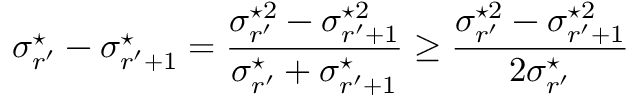Convert formula to latex. <formula><loc_0><loc_0><loc_500><loc_500>\sigma _ { r ^ { \prime } } ^ { ^ { * } } - \sigma _ { r ^ { \prime } + 1 } ^ { ^ { * } } = \frac { \sigma _ { r ^ { \prime } } ^ { ^ { * } 2 } - \sigma _ { r ^ { \prime } + 1 } ^ { ^ { * } 2 } } { \sigma _ { r ^ { \prime } } ^ { ^ { * } } + \sigma _ { r ^ { \prime } + 1 } ^ { ^ { * } } } \geq \frac { \sigma _ { r ^ { \prime } } ^ { ^ { * } 2 } - \sigma _ { r ^ { \prime } + 1 } ^ { ^ { * } 2 } } { 2 \sigma _ { r ^ { \prime } } ^ { ^ { * } } }</formula> 